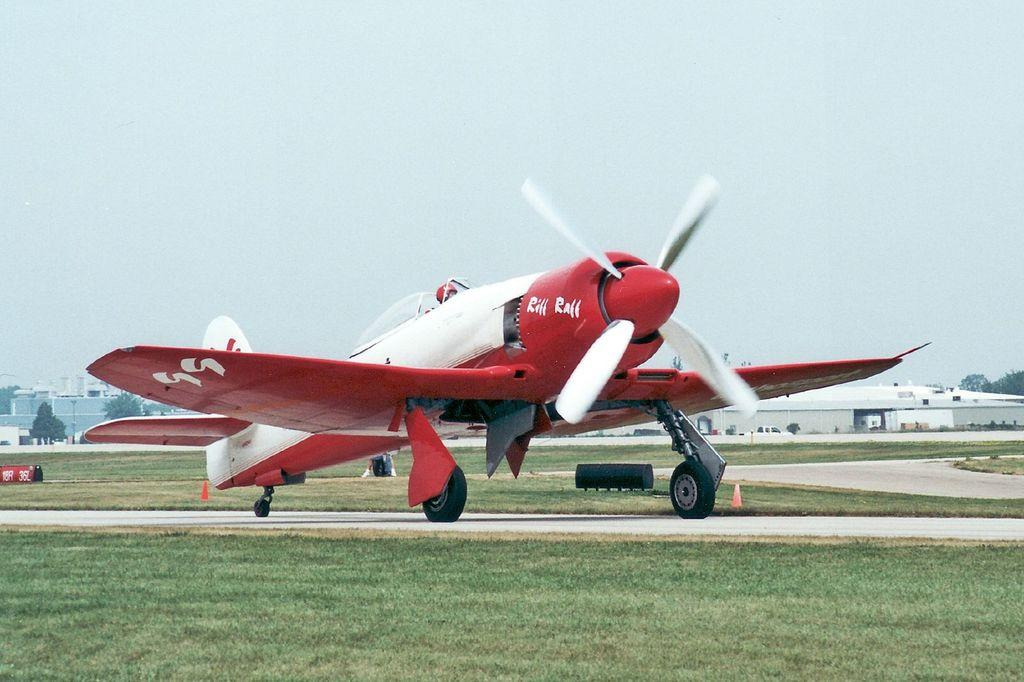What is the main subject of subject of the image? The main subject of the image is an airplane on the ground. What can be seen in the background of the image? In the background of the image, there are buildings, trees, grass, and the sky. What is the color of the object on the ground in the image? The object on the ground is red. What type of trail can be seen in the image? There is no trail present in the image. Is there a crib visible in the image? No, there is no crib present in the image. 